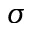Convert formula to latex. <formula><loc_0><loc_0><loc_500><loc_500>\sigma</formula> 